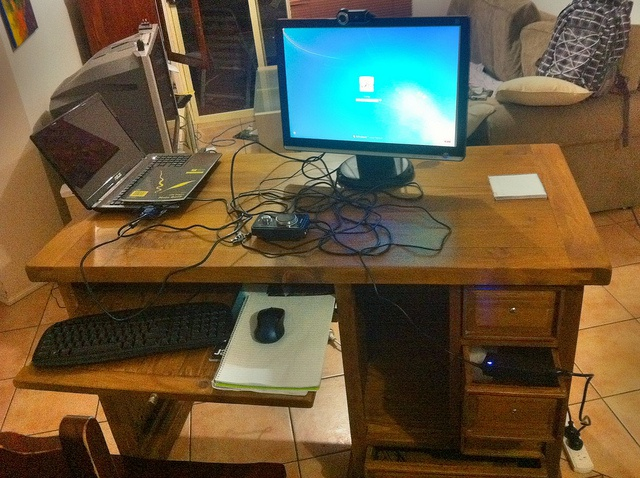Describe the objects in this image and their specific colors. I can see couch in navy, maroon, and gray tones, tv in navy, cyan, lightblue, and white tones, laptop in navy, black, and gray tones, book in navy, tan, darkgray, black, and beige tones, and keyboard in navy, black, maroon, and brown tones in this image. 